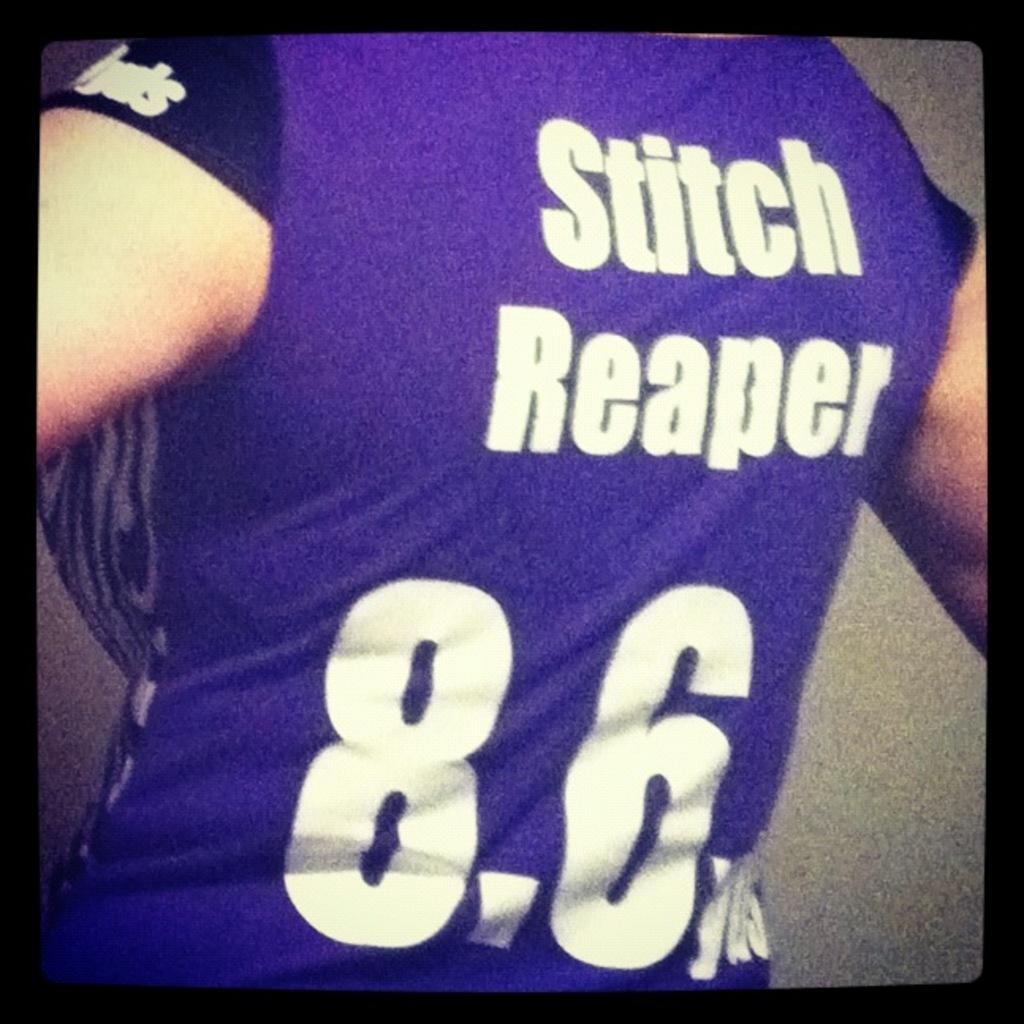<image>
Present a compact description of the photo's key features. A person wears a blue top with Stitch Reaper on the back. 